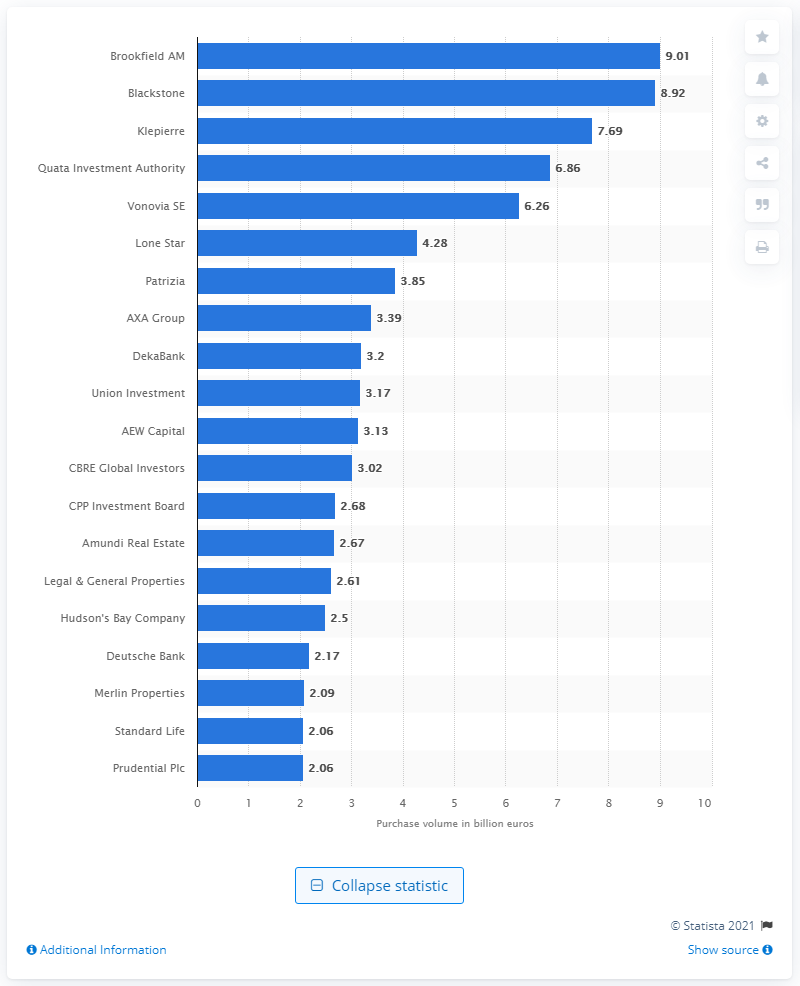List a handful of essential elements in this visual. In January 2016, Brookfield Asset Management was ranked as the top real estate investment company in the European market. The total value of Brookfield AM's purchases in January 2016 was approximately $9.01. 